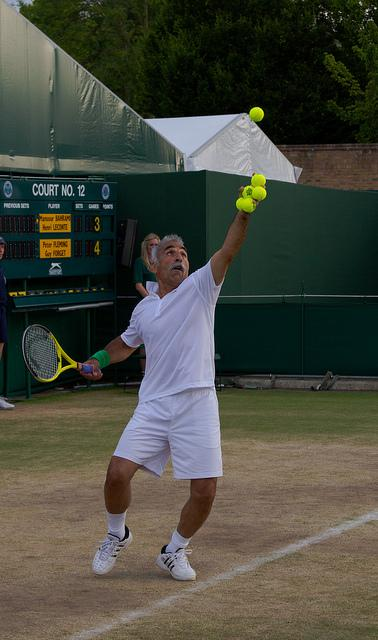Why is he holding several tennis balls?

Choices:
A) bombard opponent
B) standard gameplay
C) practicing serve
D) prevent theft practicing serve 